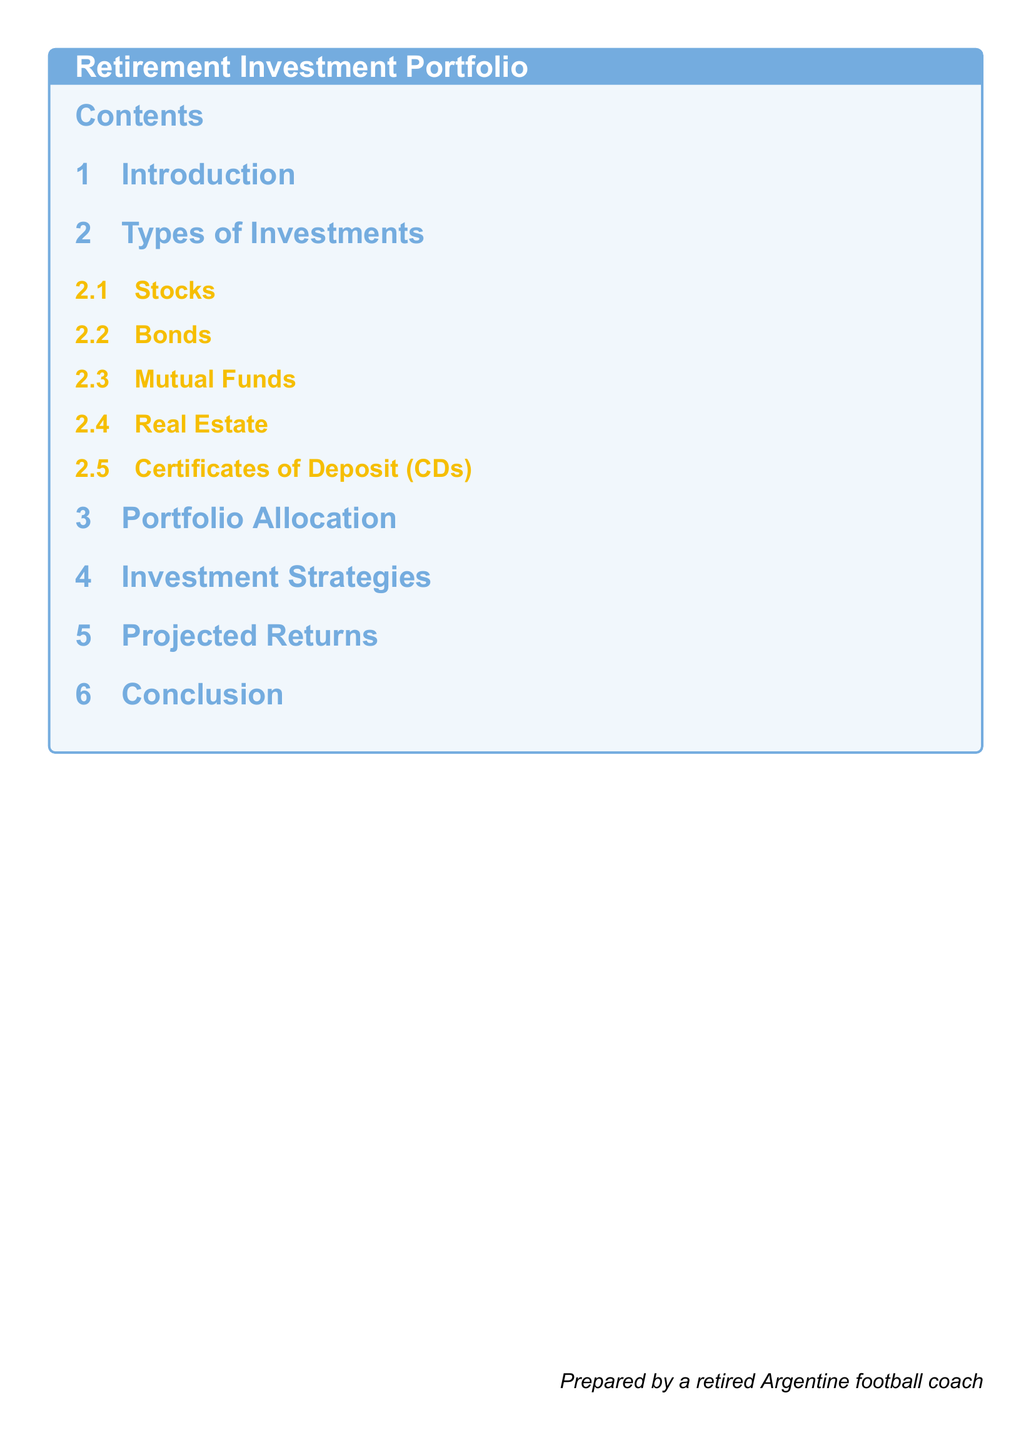What is the title of the document? The title is prominently displayed at the top of the rendered document, which is "Retirement Investment Portfolio".
Answer: Retirement Investment Portfolio How many main sections are there in the document? The number of main sections is indicated in the table of contents, specifically counting the sections listed.
Answer: 7 What section covers investment strategies? Each section title is listed in the table of contents, allowing for easy navigation to specific topics.
Answer: Investment Strategies What type of investment is listed first? The order of sub-sections is found under the "Types of Investments" main section, revealing its hierarchy.
Answer: Stocks What color is used for the section titles? The document specifies colors for different elements, which can be inferred from its formatting.
Answer: Argentine Blue What is the font used in the document? The font type can be identified from the code where the main font is set, which provides clarity on the typography used.
Answer: Arial Who prepared the document? The author is indicated at the bottom of the document, showing the individual responsible for its creation.
Answer: A retired Argentine football coach 